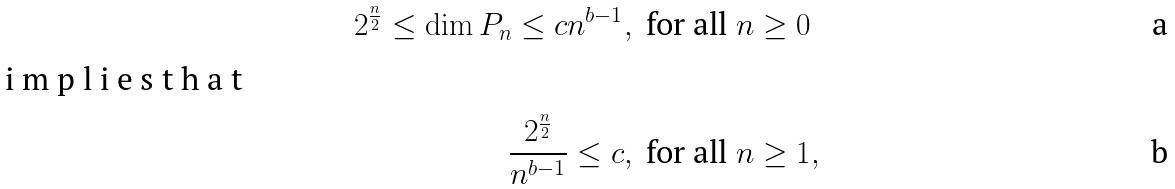<formula> <loc_0><loc_0><loc_500><loc_500>2 ^ { \frac { n } { 2 } } \leq \dim P _ { n } \leq c n ^ { b - 1 } , \, & \text { for all $n\geq 0$} \\ \intertext { i m p l i e s t h a t } \frac { 2 ^ { \frac { n } { 2 } } } { n ^ { b - 1 } } \leq c , \, & \text { for all $n\geq 1$} ,</formula> 